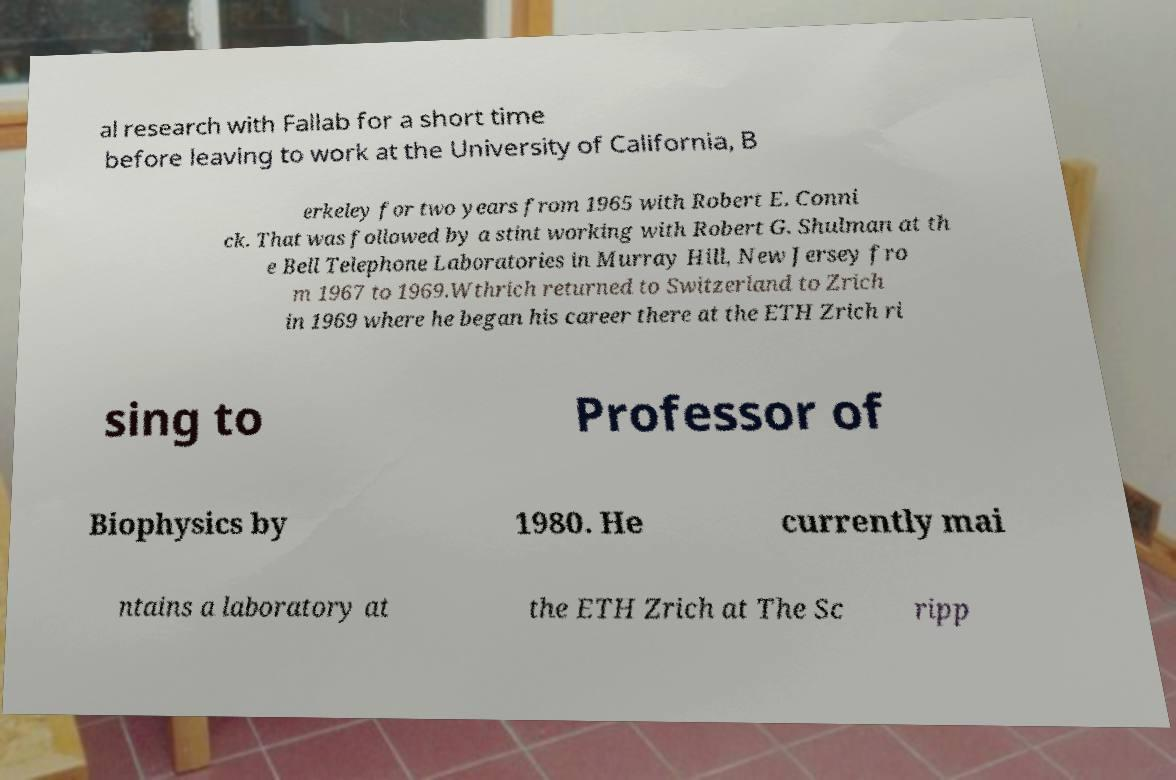Could you assist in decoding the text presented in this image and type it out clearly? al research with Fallab for a short time before leaving to work at the University of California, B erkeley for two years from 1965 with Robert E. Conni ck. That was followed by a stint working with Robert G. Shulman at th e Bell Telephone Laboratories in Murray Hill, New Jersey fro m 1967 to 1969.Wthrich returned to Switzerland to Zrich in 1969 where he began his career there at the ETH Zrich ri sing to Professor of Biophysics by 1980. He currently mai ntains a laboratory at the ETH Zrich at The Sc ripp 